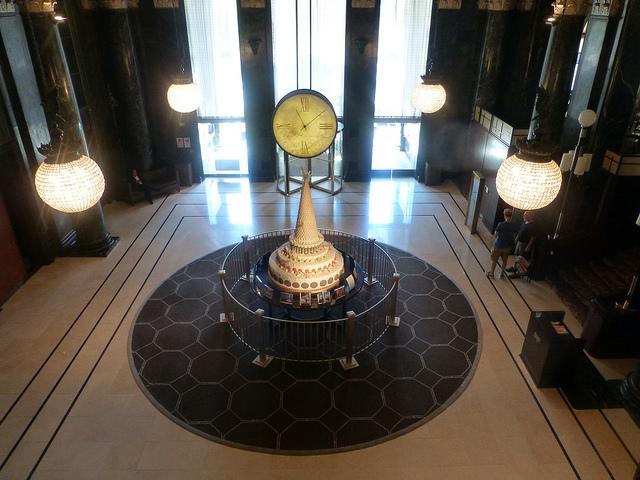What  is hanging from ceiling?
Quick response, please. Lights. Is there a vase in the middle of the room?
Quick response, please. No. Do you see a clock?
Quick response, please. Yes. 